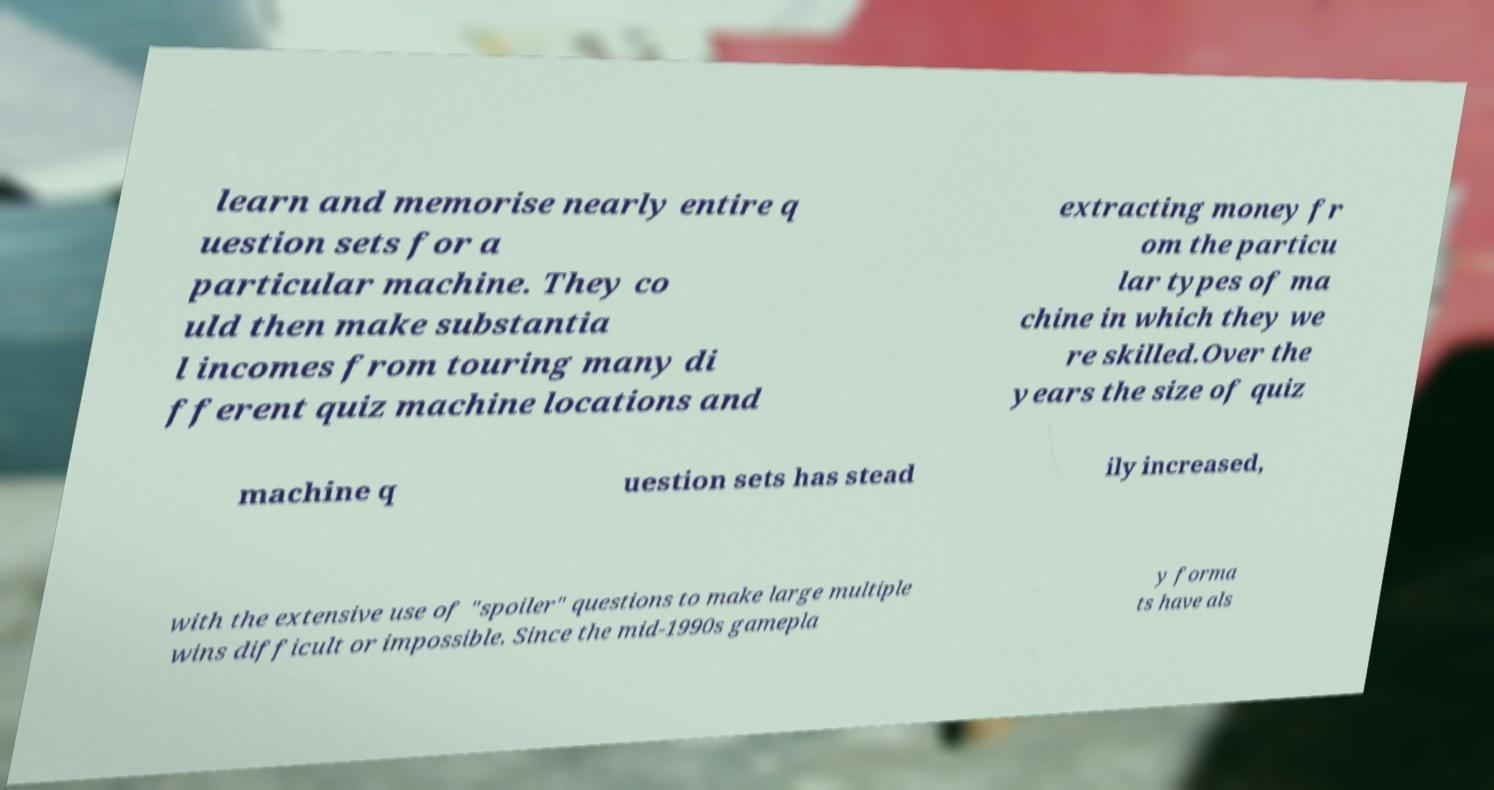Can you accurately transcribe the text from the provided image for me? learn and memorise nearly entire q uestion sets for a particular machine. They co uld then make substantia l incomes from touring many di fferent quiz machine locations and extracting money fr om the particu lar types of ma chine in which they we re skilled.Over the years the size of quiz machine q uestion sets has stead ily increased, with the extensive use of "spoiler" questions to make large multiple wins difficult or impossible. Since the mid-1990s gamepla y forma ts have als 